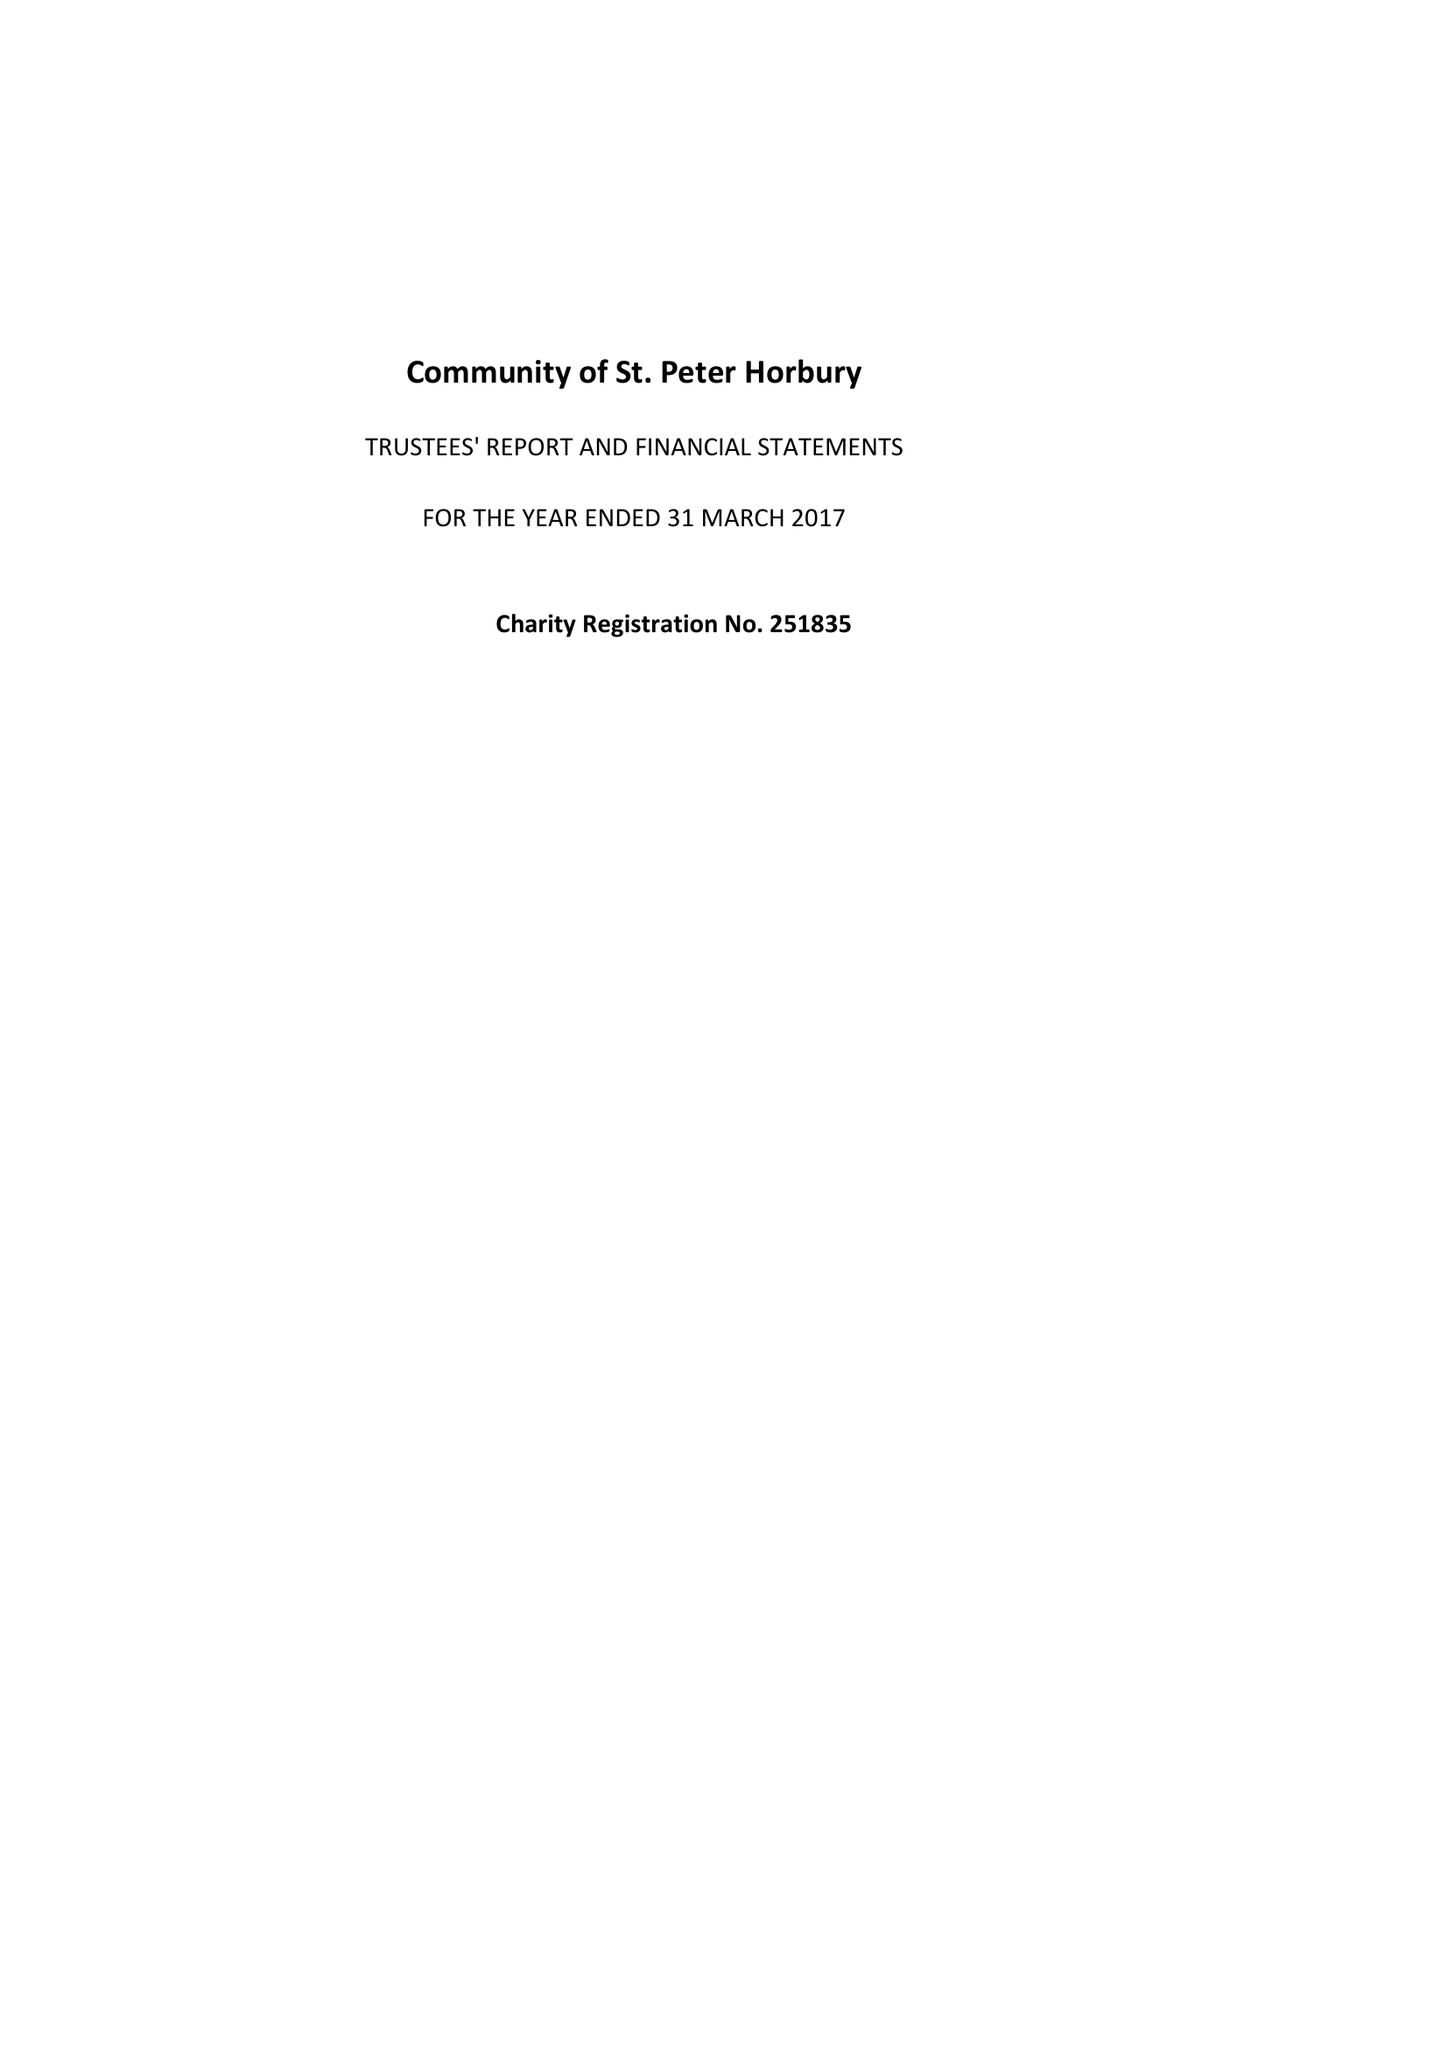What is the value for the address__street_line?
Answer the question using a single word or phrase. 14 SPRING END ROAD 